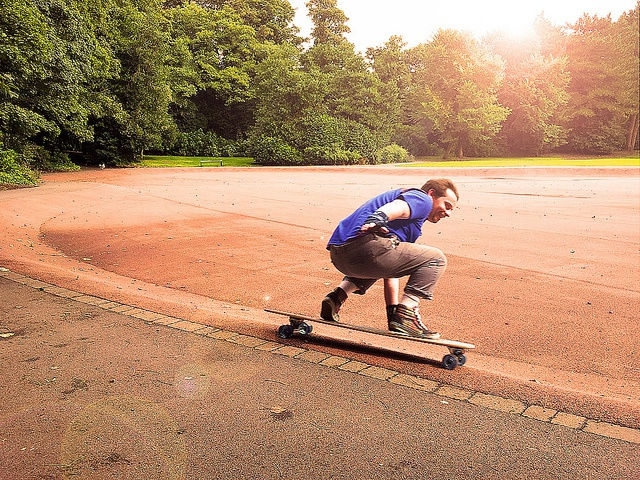Describe the objects in this image and their specific colors. I can see people in black, maroon, white, and brown tones, skateboard in black, ivory, maroon, and gray tones, and bench in black, tan, olive, and khaki tones in this image. 